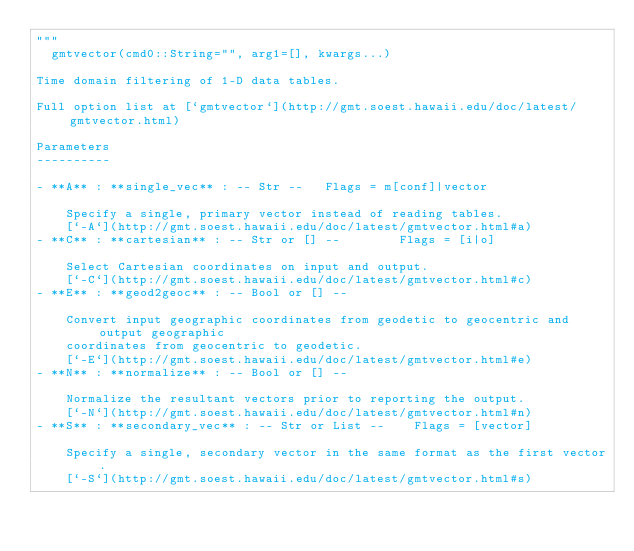Convert code to text. <code><loc_0><loc_0><loc_500><loc_500><_Julia_>"""
	gmtvector(cmd0::String="", arg1=[], kwargs...)

Time domain filtering of 1-D data tables.

Full option list at [`gmtvector`](http://gmt.soest.hawaii.edu/doc/latest/gmtvector.html)

Parameters
----------

- **A** : **single_vec** : -- Str --   Flags = m[conf]|vector

    Specify a single, primary vector instead of reading tables.
    [`-A`](http://gmt.soest.hawaii.edu/doc/latest/gmtvector.html#a)
- **C** : **cartesian** : -- Str or [] --        Flags = [i|o]

    Select Cartesian coordinates on input and output.
    [`-C`](http://gmt.soest.hawaii.edu/doc/latest/gmtvector.html#c)
- **E** : **geod2geoc** : -- Bool or [] --

    Convert input geographic coordinates from geodetic to geocentric and output geographic
    coordinates from geocentric to geodetic.
    [`-E`](http://gmt.soest.hawaii.edu/doc/latest/gmtvector.html#e)
- **N** : **normalize** : -- Bool or [] --

    Normalize the resultant vectors prior to reporting the output.
    [`-N`](http://gmt.soest.hawaii.edu/doc/latest/gmtvector.html#n)
- **S** : **secondary_vec** : -- Str or List --    Flags = [vector]

    Specify a single, secondary vector in the same format as the first vector.
    [`-S`](http://gmt.soest.hawaii.edu/doc/latest/gmtvector.html#s)</code> 